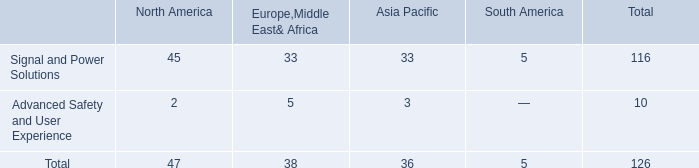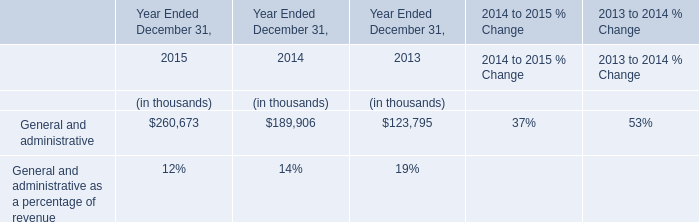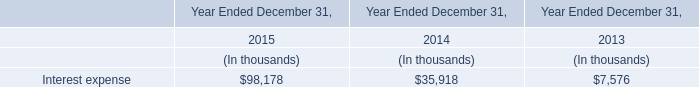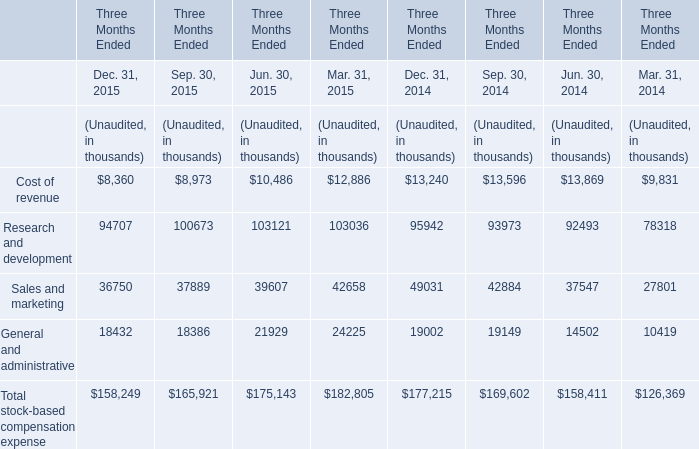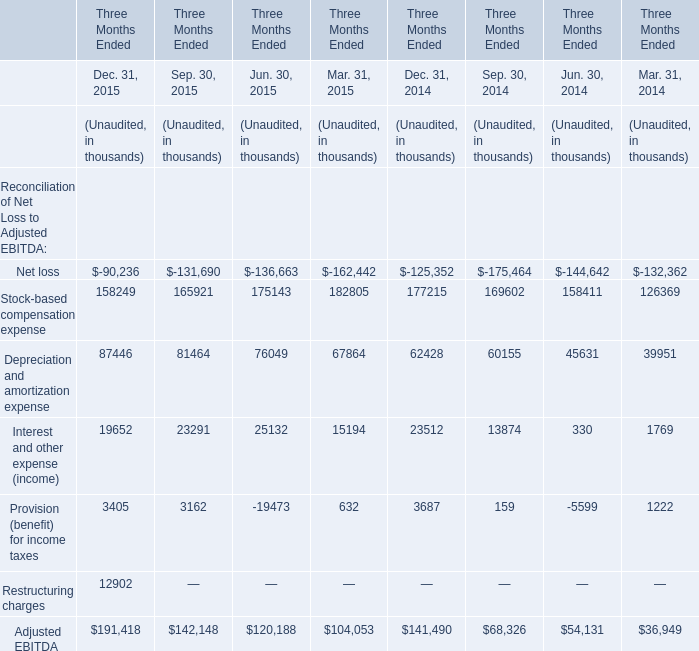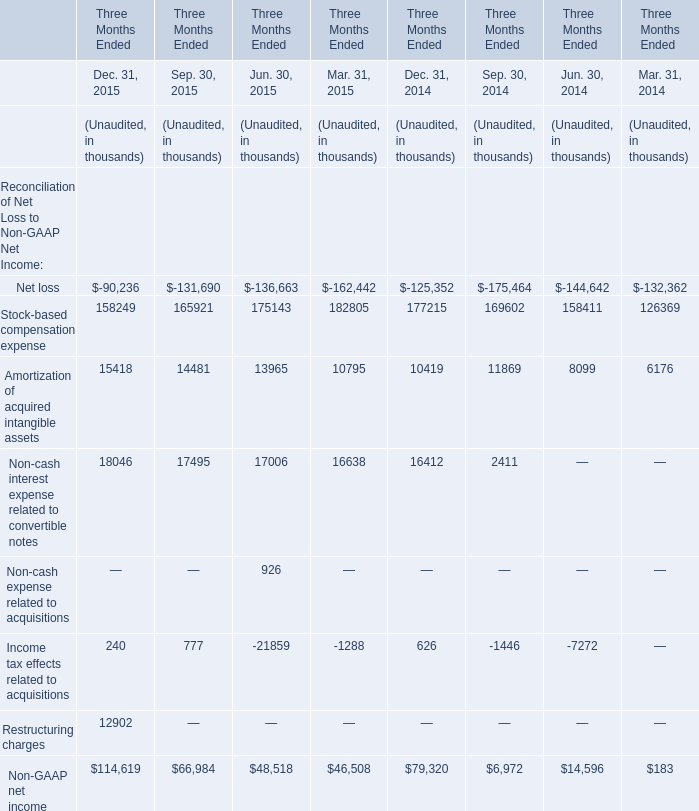In the year where Amortization of acquired intangible assets in the second quarter Unaudited is lower, what's the increasing rate of Stock-based compensation expense in the second quarter Unaudited? 
Computations: ((175143 - 158411) / 158411)
Answer: 0.10562. 